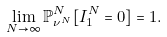Convert formula to latex. <formula><loc_0><loc_0><loc_500><loc_500>\lim _ { N \to \infty } \mathbb { P } _ { \nu ^ { N } } ^ { N } [ I _ { 1 } ^ { N } = 0 ] = 1 .</formula> 